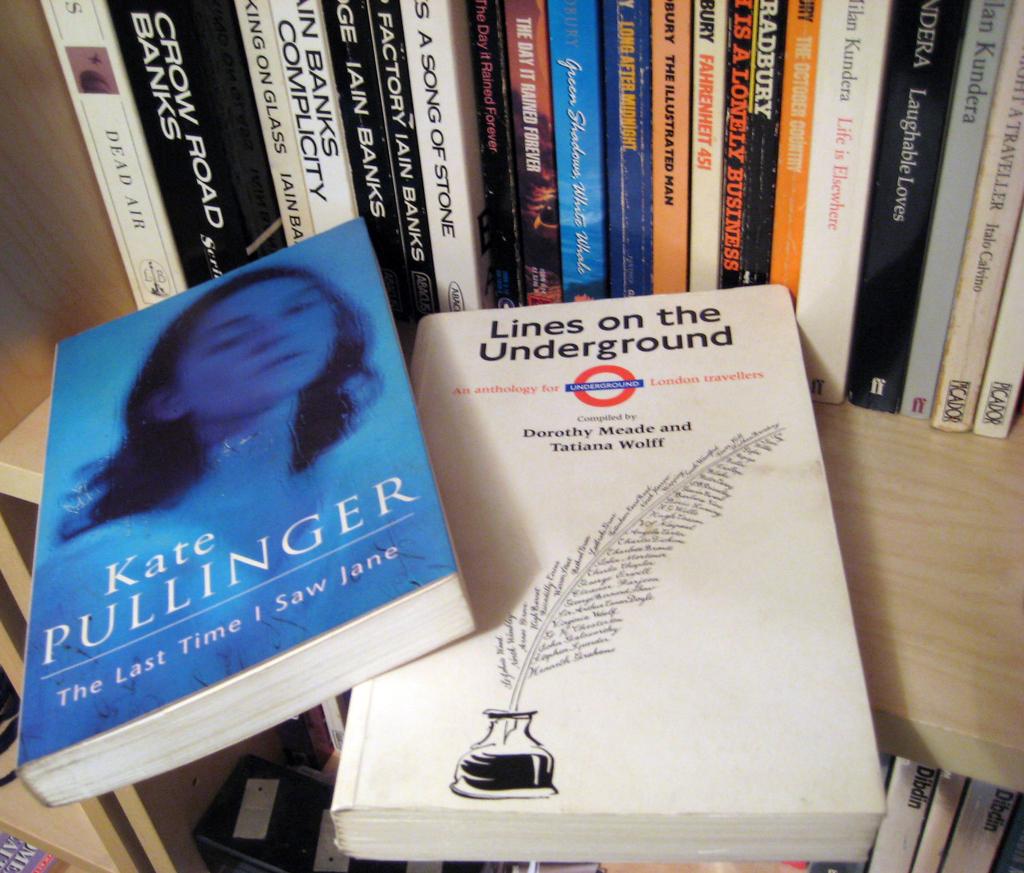Who are the authors of "lines on the underground"?
Give a very brief answer. Dorothy meade and tatiana wolff. 